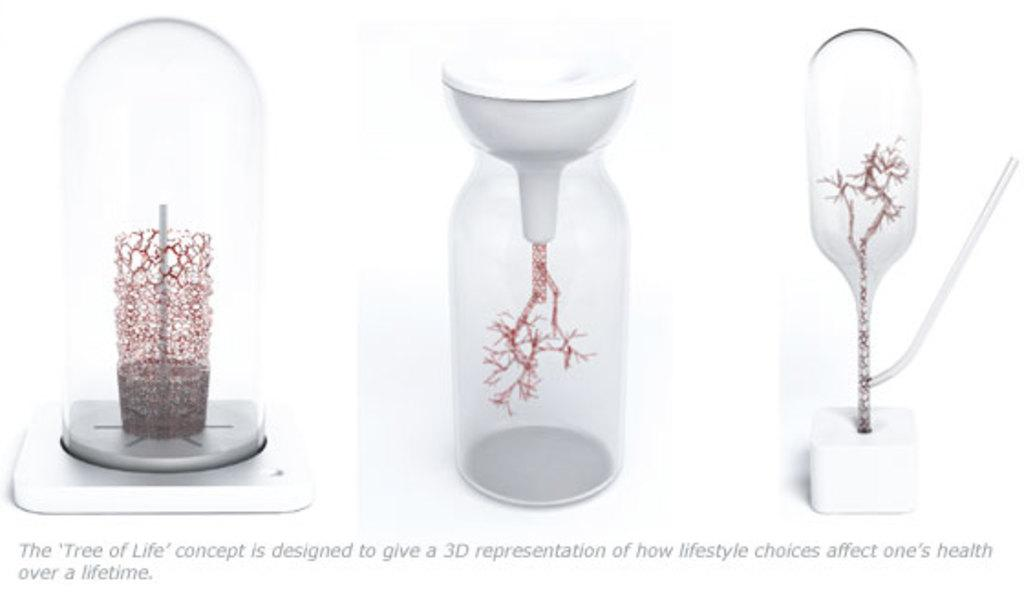What can be seen in the image related to 3D printing? There are three 3D printings of objects in the image. Is there any text present in the image? Yes, there is a text in the image. What is the color of the background in the image? The background of the image is white. What type of jelly is being used to hold the 3D printings in the image? There is no jelly present in the image. 